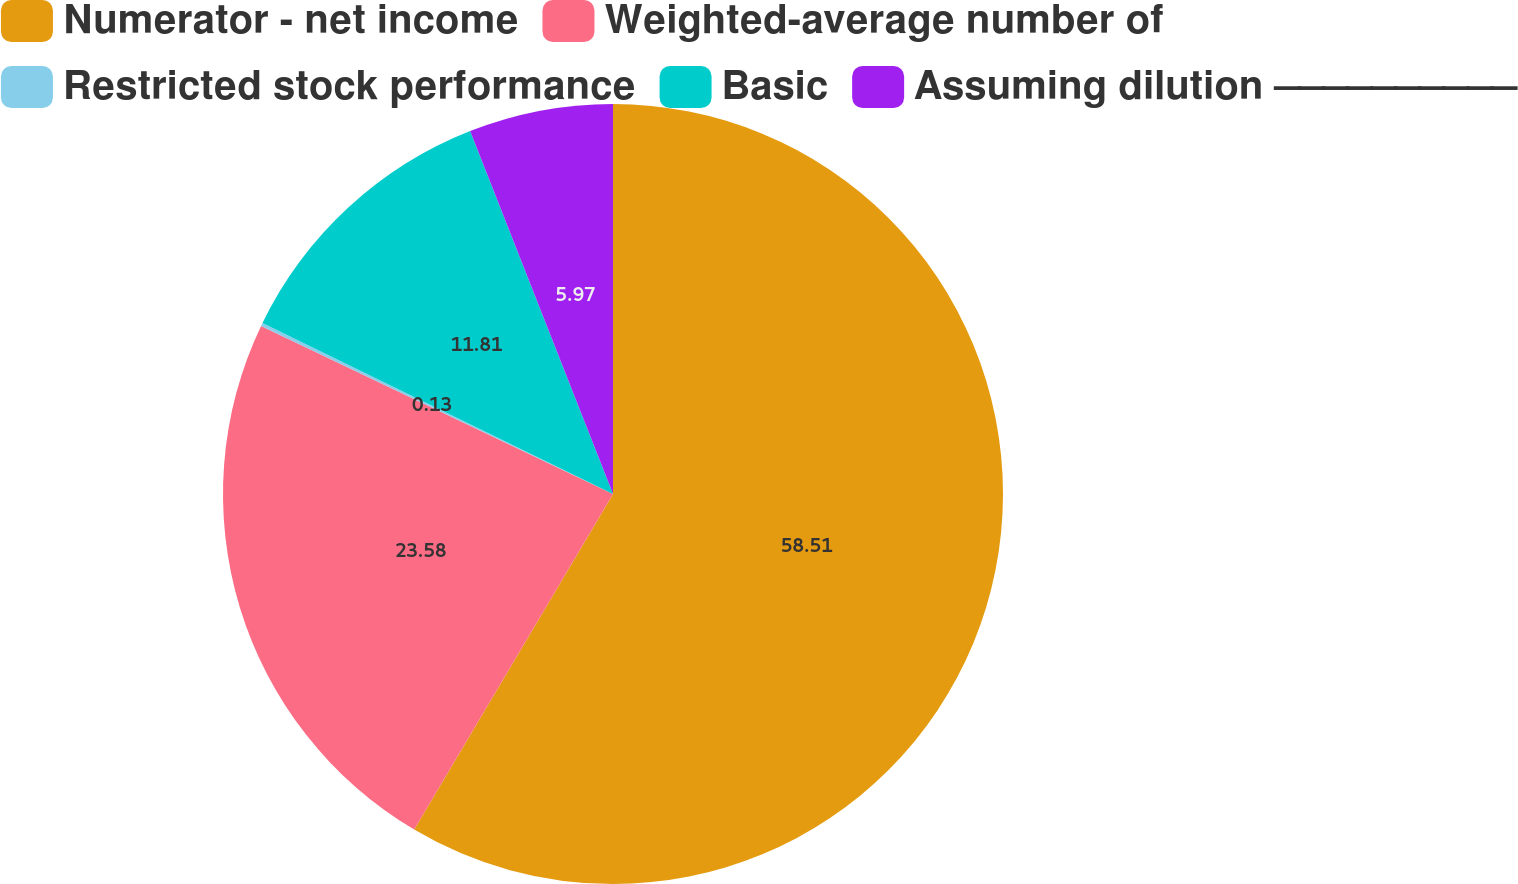<chart> <loc_0><loc_0><loc_500><loc_500><pie_chart><fcel>Numerator - net income<fcel>Weighted-average number of<fcel>Restricted stock performance<fcel>Basic<fcel>Assuming dilution ⎯⎯⎯⎯⎯⎯⎯⎯⎯⎯<nl><fcel>58.52%<fcel>23.58%<fcel>0.13%<fcel>11.81%<fcel>5.97%<nl></chart> 